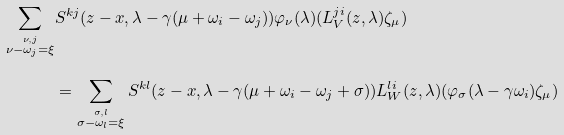<formula> <loc_0><loc_0><loc_500><loc_500>\sum _ { \overset { \nu , j } { \nu - \omega _ { j } = \xi } } & S ^ { k j } ( z - x , \lambda - \gamma ( \mu + \omega _ { i } - \omega _ { j } ) ) \varphi _ { \nu } ( \lambda ) ( L _ { V } ^ { j i } ( z , \lambda ) \zeta _ { \mu } ) \\ & = \sum _ { \overset { \sigma , l } { \sigma - \omega _ { l } = \xi } } S ^ { k l } ( z - x , \lambda - \gamma ( \mu + \omega _ { i } - \omega _ { j } + \sigma ) ) L ^ { l i } _ { W } ( z , \lambda ) ( \varphi _ { \sigma } ( \lambda - \gamma \omega _ { i } ) \zeta _ { \mu } )</formula> 